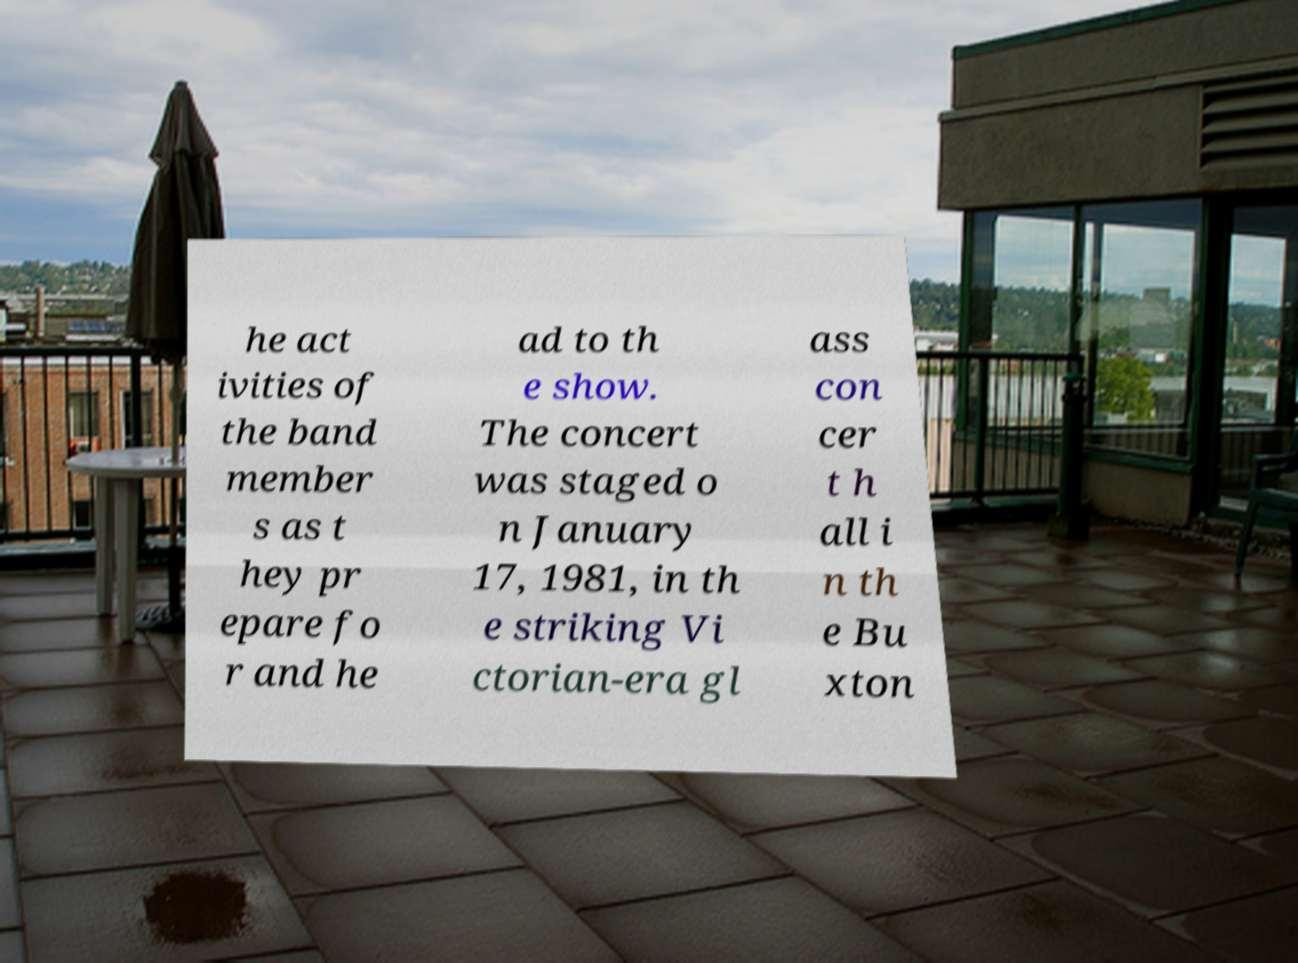I need the written content from this picture converted into text. Can you do that? he act ivities of the band member s as t hey pr epare fo r and he ad to th e show. The concert was staged o n January 17, 1981, in th e striking Vi ctorian-era gl ass con cer t h all i n th e Bu xton 